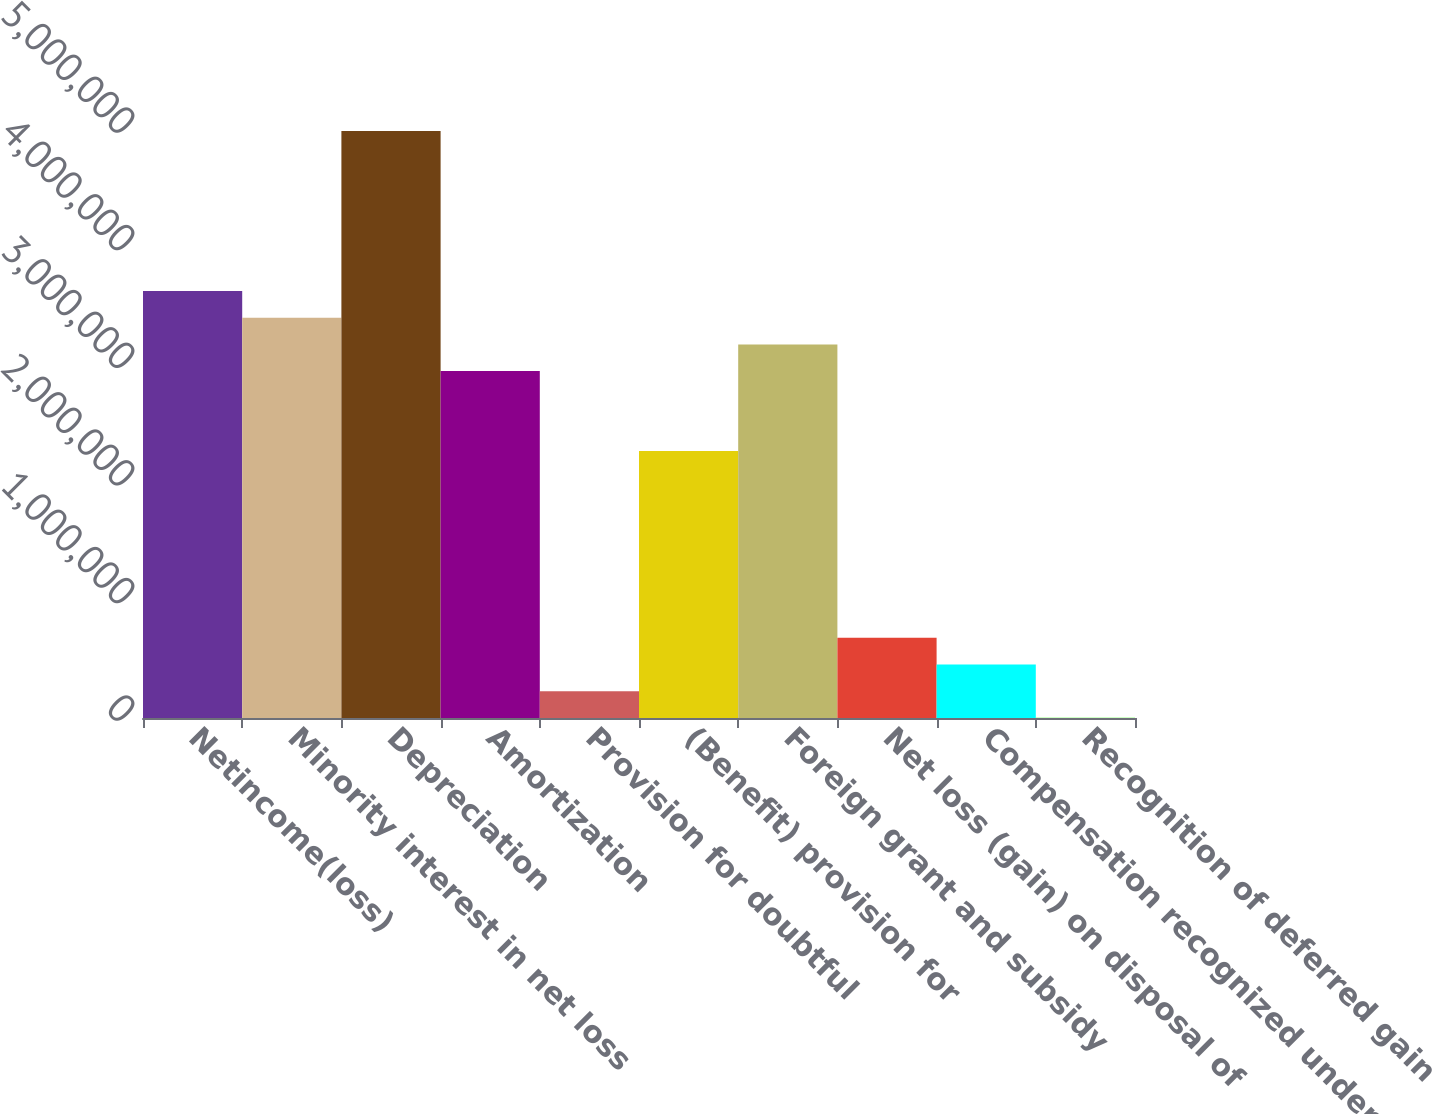Convert chart to OTSL. <chart><loc_0><loc_0><loc_500><loc_500><bar_chart><fcel>Netincome(loss)<fcel>Minority interest in net loss<fcel>Depreciation<fcel>Amortization<fcel>Provision for doubtful<fcel>(Benefit) provision for<fcel>Foreign grant and subsidy<fcel>Net loss (gain) on disposal of<fcel>Compensation recognized under<fcel>Recognition of deferred gain<nl><fcel>3.63032e+06<fcel>3.40353e+06<fcel>4.99106e+06<fcel>2.94995e+06<fcel>228470<fcel>2.26958e+06<fcel>3.17674e+06<fcel>682051<fcel>455260<fcel>1680<nl></chart> 